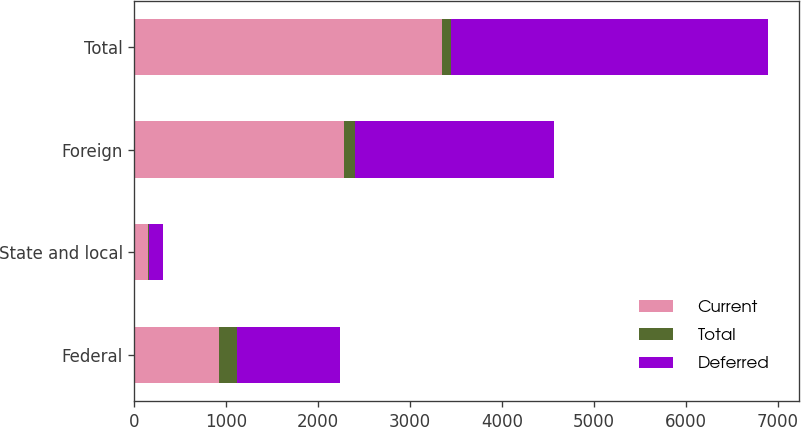Convert chart to OTSL. <chart><loc_0><loc_0><loc_500><loc_500><stacked_bar_chart><ecel><fcel>Federal<fcel>State and local<fcel>Foreign<fcel>Total<nl><fcel>Current<fcel>923<fcel>146<fcel>2283<fcel>3352<nl><fcel>Total<fcel>193<fcel>12<fcel>112<fcel>93<nl><fcel>Deferred<fcel>1116<fcel>158<fcel>2171<fcel>3445<nl></chart> 